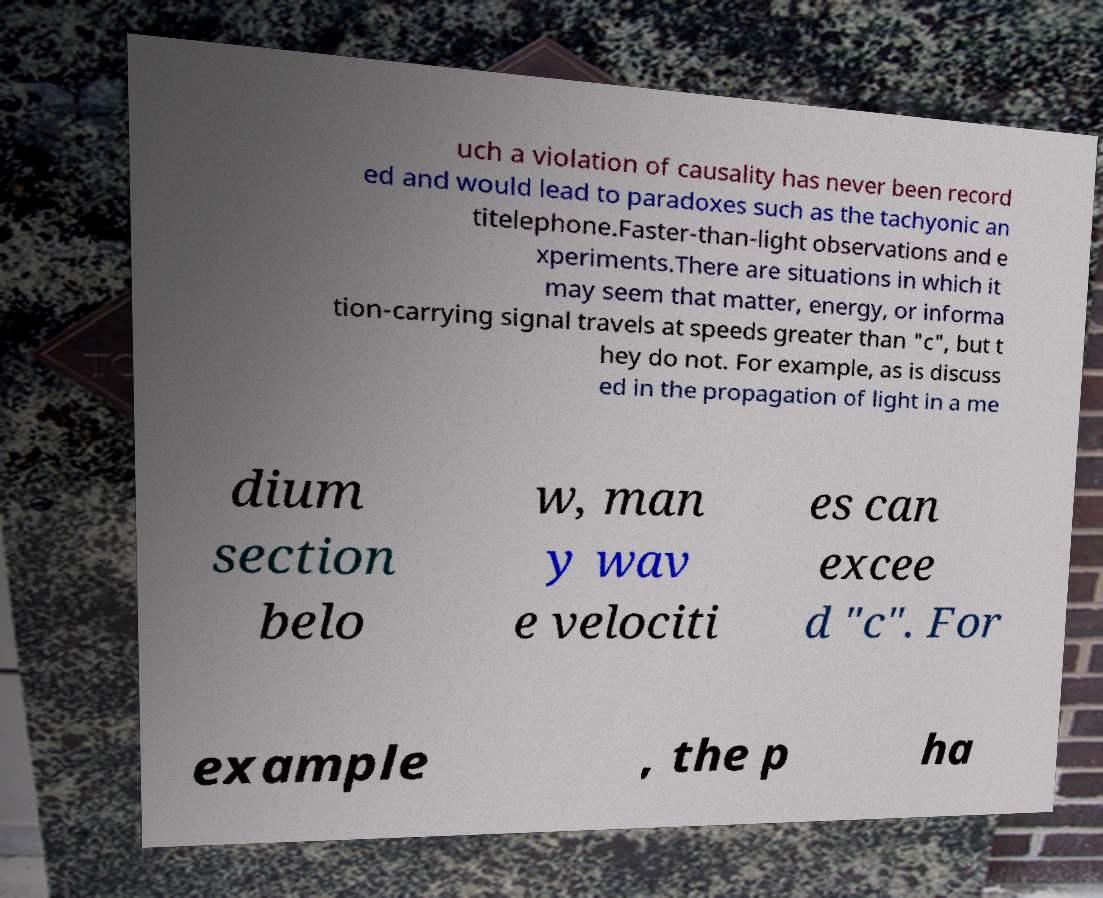Please read and relay the text visible in this image. What does it say? uch a violation of causality has never been record ed and would lead to paradoxes such as the tachyonic an titelephone.Faster-than-light observations and e xperiments.There are situations in which it may seem that matter, energy, or informa tion-carrying signal travels at speeds greater than "c", but t hey do not. For example, as is discuss ed in the propagation of light in a me dium section belo w, man y wav e velociti es can excee d "c". For example , the p ha 